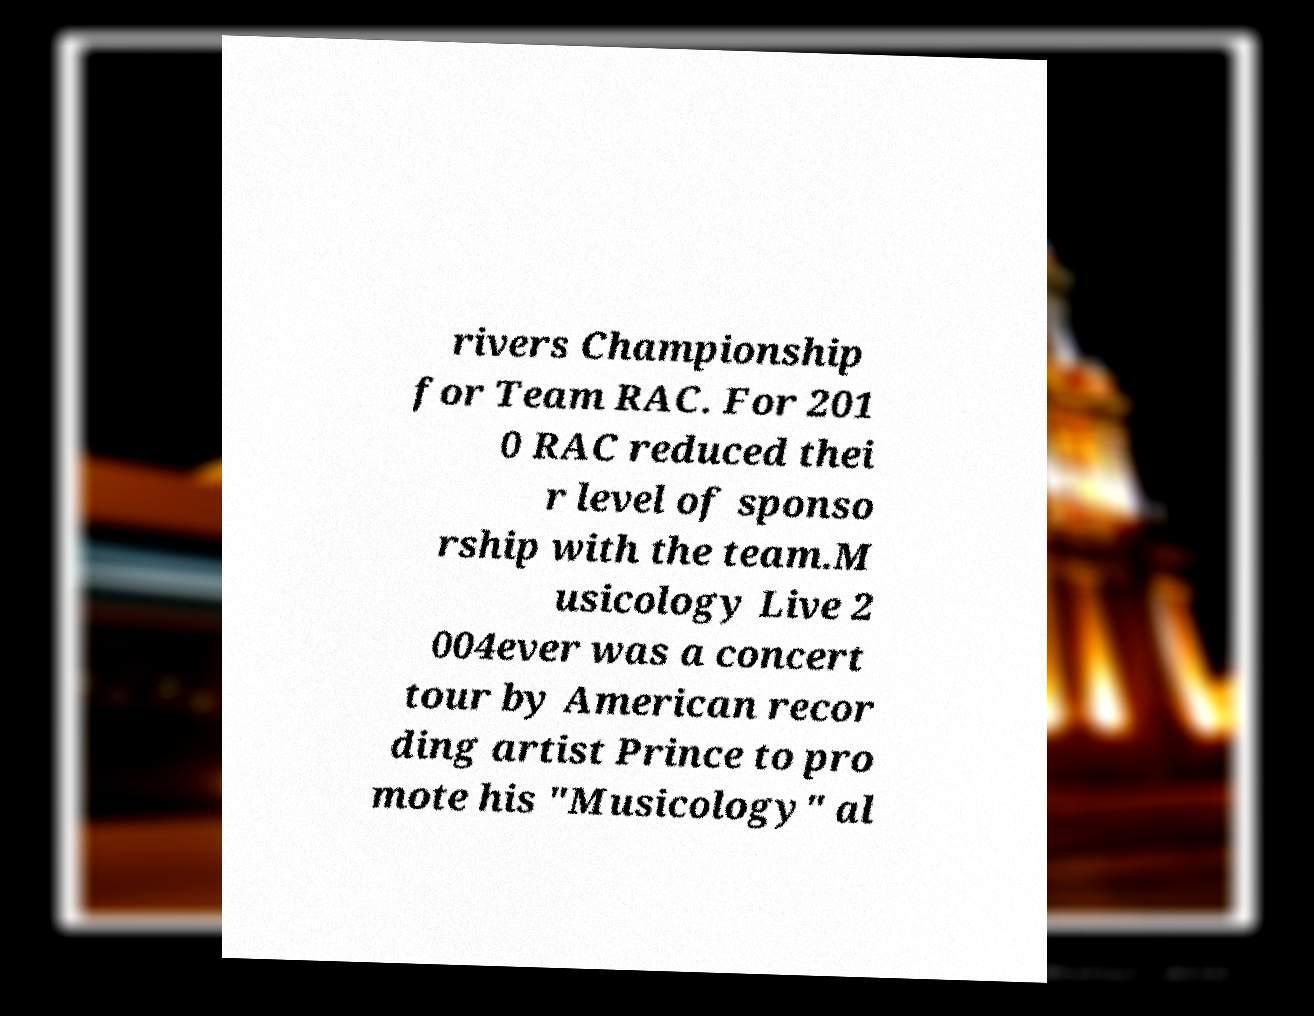Please identify and transcribe the text found in this image. rivers Championship for Team RAC. For 201 0 RAC reduced thei r level of sponso rship with the team.M usicology Live 2 004ever was a concert tour by American recor ding artist Prince to pro mote his "Musicology" al 